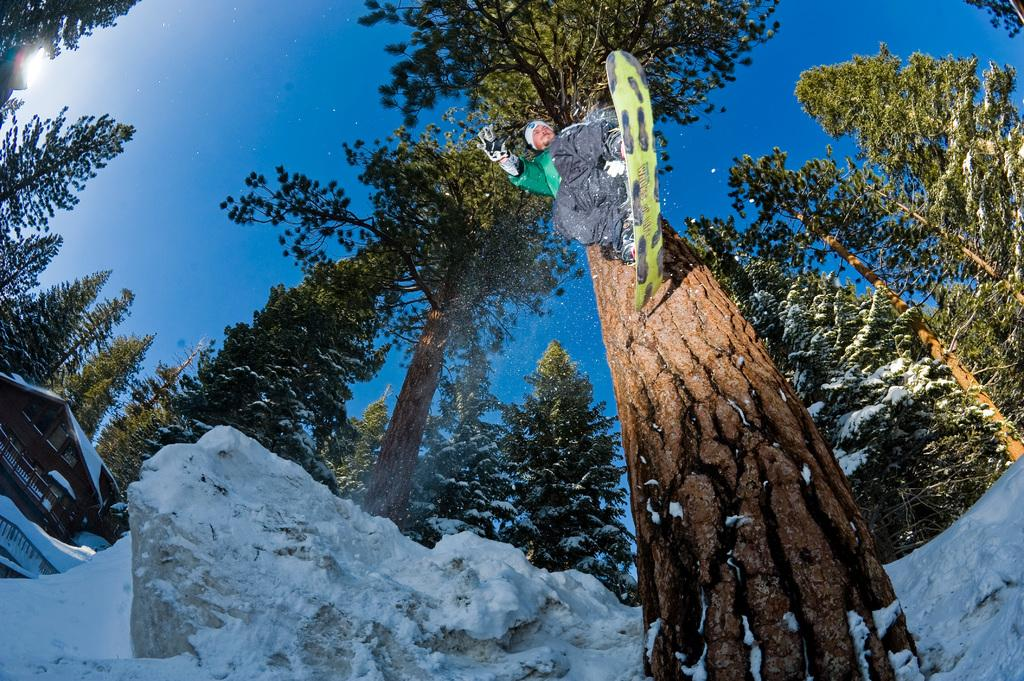What structure is present in the image? There is a building in the image. What is the man in the image doing? The man is standing on a snowboard and jumping. What accessories is the man wearing? The man is wearing a cap on his head and gloves on his hands. What is the weather like in the image? There is snow visible in the image, and the sky is blue. Can you tell me how many clams are visible in the image? There are no clams present in the image. What type of receipt is the man holding in his hand while jumping? The man is not holding a receipt in his hand; he is wearing gloves. 